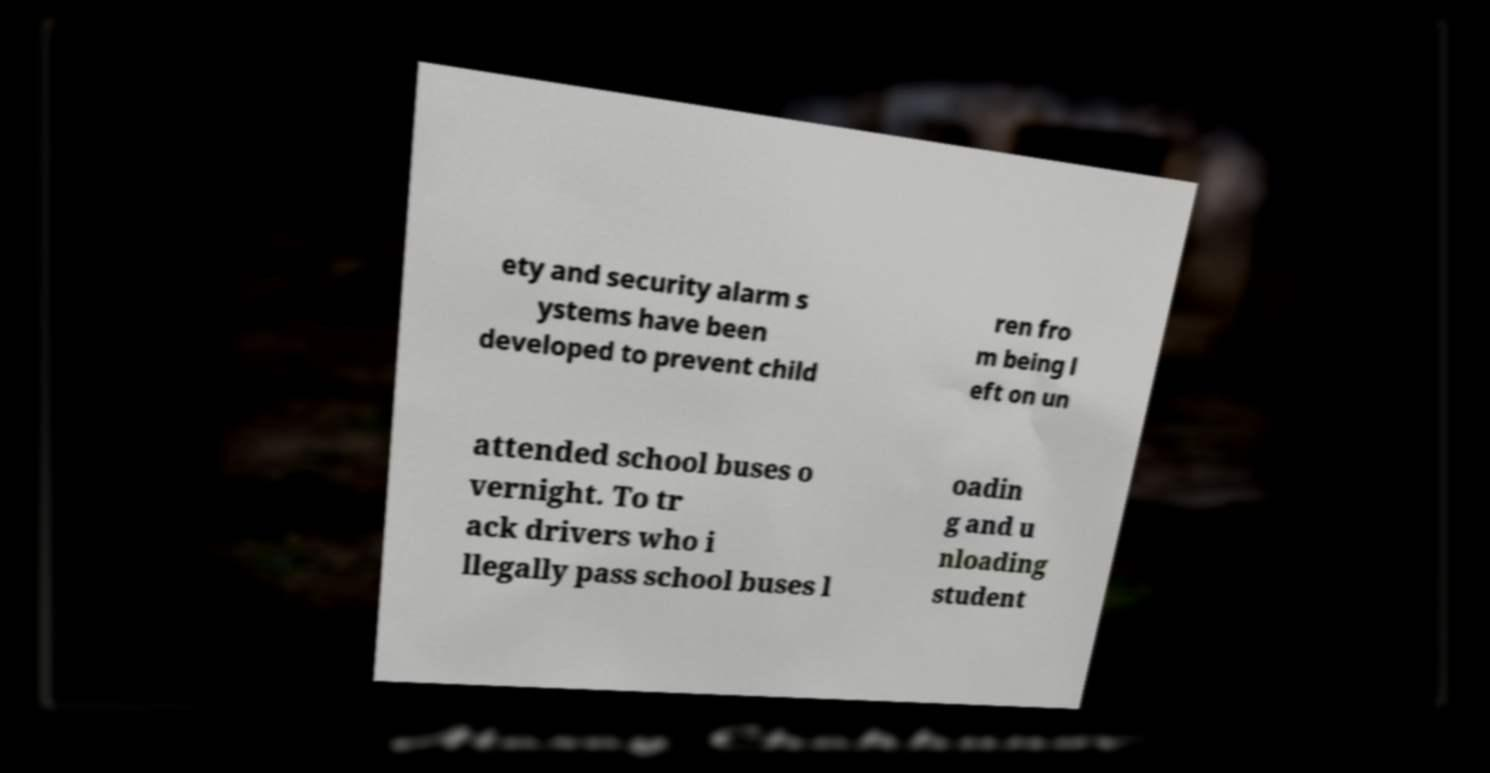Can you accurately transcribe the text from the provided image for me? ety and security alarm s ystems have been developed to prevent child ren fro m being l eft on un attended school buses o vernight. To tr ack drivers who i llegally pass school buses l oadin g and u nloading student 